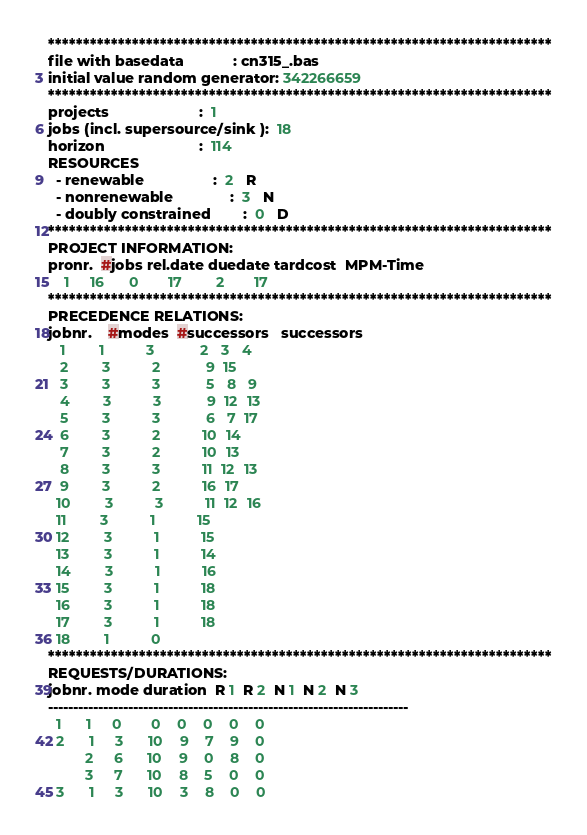<code> <loc_0><loc_0><loc_500><loc_500><_ObjectiveC_>************************************************************************
file with basedata            : cn315_.bas
initial value random generator: 342266659
************************************************************************
projects                      :  1
jobs (incl. supersource/sink ):  18
horizon                       :  114
RESOURCES
  - renewable                 :  2   R
  - nonrenewable              :  3   N
  - doubly constrained        :  0   D
************************************************************************
PROJECT INFORMATION:
pronr.  #jobs rel.date duedate tardcost  MPM-Time
    1     16      0       17        2       17
************************************************************************
PRECEDENCE RELATIONS:
jobnr.    #modes  #successors   successors
   1        1          3           2   3   4
   2        3          2           9  15
   3        3          3           5   8   9
   4        3          3           9  12  13
   5        3          3           6   7  17
   6        3          2          10  14
   7        3          2          10  13
   8        3          3          11  12  13
   9        3          2          16  17
  10        3          3          11  12  16
  11        3          1          15
  12        3          1          15
  13        3          1          14
  14        3          1          16
  15        3          1          18
  16        3          1          18
  17        3          1          18
  18        1          0        
************************************************************************
REQUESTS/DURATIONS:
jobnr. mode duration  R 1  R 2  N 1  N 2  N 3
------------------------------------------------------------------------
  1      1     0       0    0    0    0    0
  2      1     3      10    9    7    9    0
         2     6      10    9    0    8    0
         3     7      10    8    5    0    0
  3      1     3      10    3    8    0    0</code> 